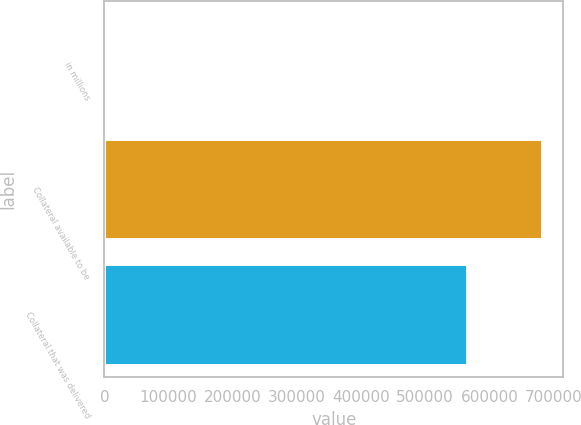<chart> <loc_0><loc_0><loc_500><loc_500><bar_chart><fcel>in millions<fcel>Collateral available to be<fcel>Collateral that was delivered<nl><fcel>2018<fcel>681516<fcel>565625<nl></chart> 